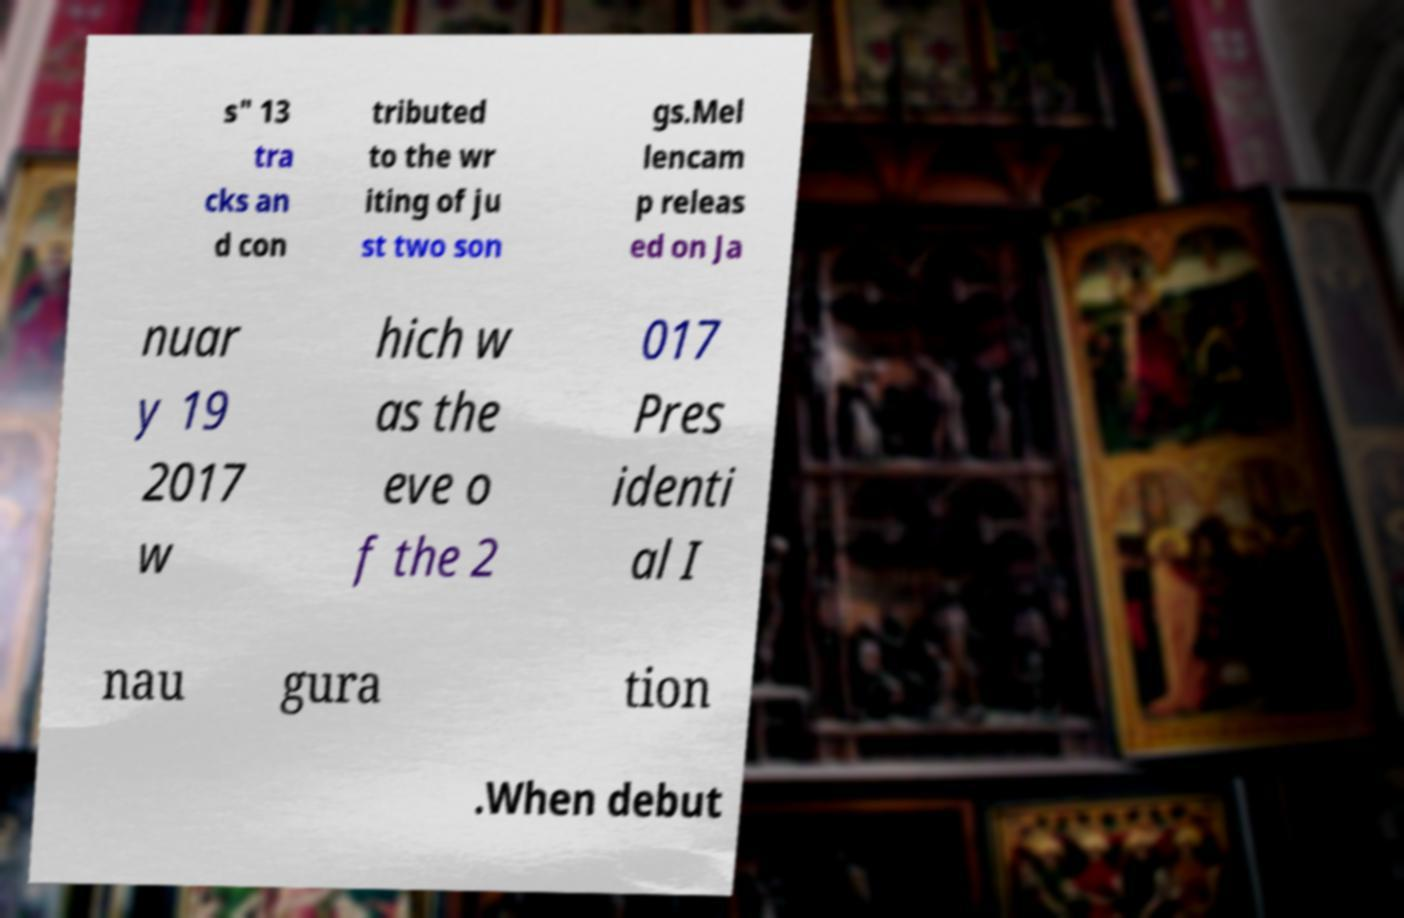Could you extract and type out the text from this image? s" 13 tra cks an d con tributed to the wr iting of ju st two son gs.Mel lencam p releas ed on Ja nuar y 19 2017 w hich w as the eve o f the 2 017 Pres identi al I nau gura tion .When debut 